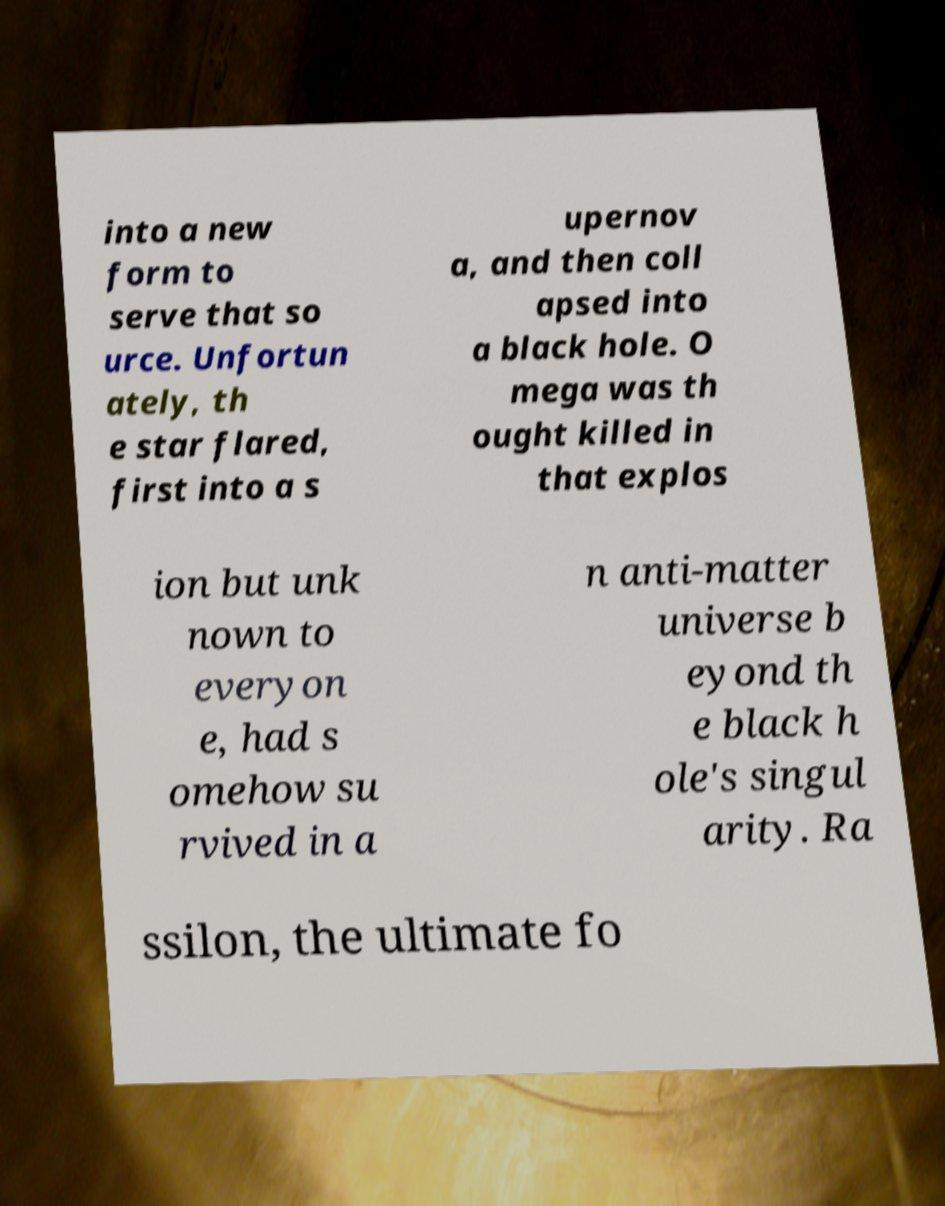Could you extract and type out the text from this image? into a new form to serve that so urce. Unfortun ately, th e star flared, first into a s upernov a, and then coll apsed into a black hole. O mega was th ought killed in that explos ion but unk nown to everyon e, had s omehow su rvived in a n anti-matter universe b eyond th e black h ole's singul arity. Ra ssilon, the ultimate fo 